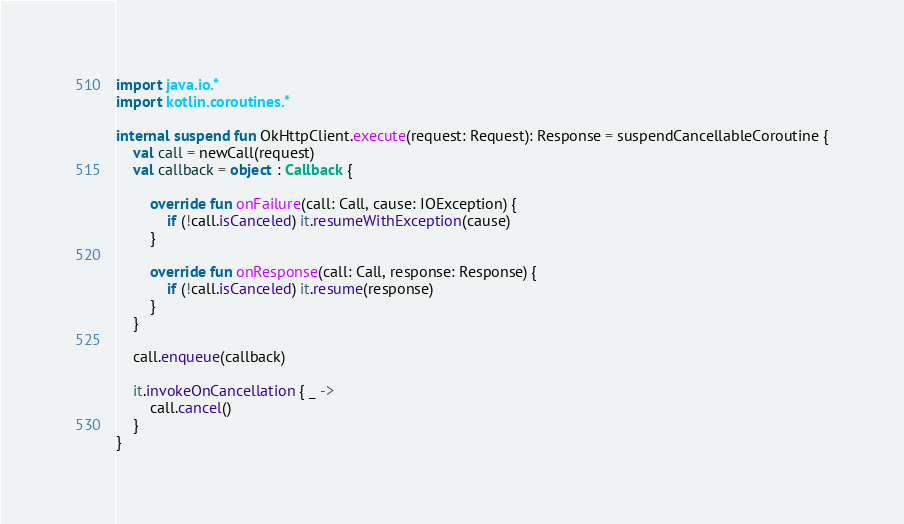<code> <loc_0><loc_0><loc_500><loc_500><_Kotlin_>import java.io.*
import kotlin.coroutines.*

internal suspend fun OkHttpClient.execute(request: Request): Response = suspendCancellableCoroutine {
    val call = newCall(request)
    val callback = object : Callback {

        override fun onFailure(call: Call, cause: IOException) {
            if (!call.isCanceled) it.resumeWithException(cause)
        }

        override fun onResponse(call: Call, response: Response) {
            if (!call.isCanceled) it.resume(response)
        }
    }

    call.enqueue(callback)

    it.invokeOnCancellation { _ ->
        call.cancel()
    }
}
</code> 